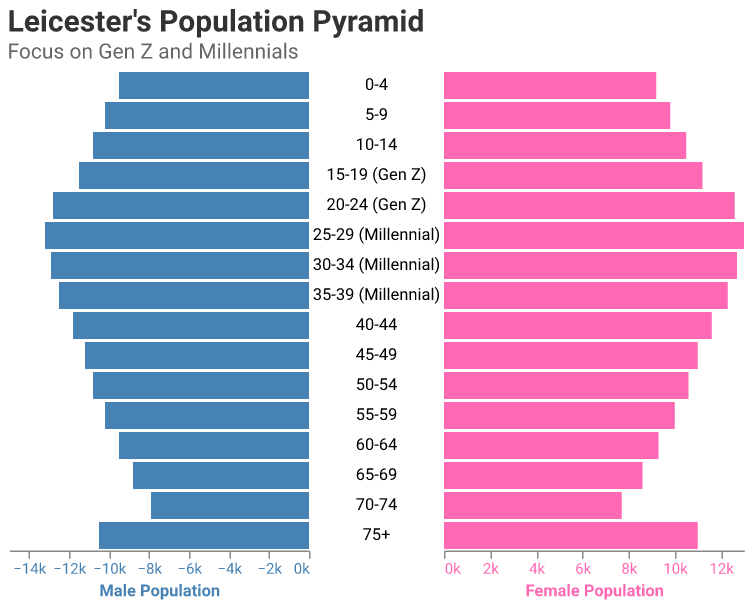What is the title of the figure? The title of the figure is displayed prominently at the top and says "Leicester's Population Pyramid", with a subtitle "Focus on Gen Z and Millennials".
Answer: Leicester's Population Pyramid What age group has the highest male population among Millennials? By examining the bars representing Millennials, the age group "25-29" has the longest bar for males, indicating the highest population.
Answer: 25-29 How does the female population of the 20-24 age group (Gen Z) compare to the male population of the same group? The female population bar for the 20-24 age group is slightly shorter than the male bar. The tooltip also shows females at 12,600 and males at 12,800.
Answer: Female population is slightly lower What is the total population (male and female) of the 35-39 age group (Millennial)? The male population is 12,500 and the female population is 12,300. Adding them together: 12,500 + 12,300 = 24,800.
Answer: 24,800 Which generation, Gen Z or Millennials, has a higher total population in Leicester? Summing the populations of each age group for both generations: 
- Gen Z: (11,500 + 11,200) + (12,800 + 12,600) = 48,100
- Millennials: (13,200 + 13,000) + (12,900 + 12,700) + (12,500 + 12,300) = 76,600
Therefore, Millennials have a higher total population.
Answer: Millennials What is the difference in male population between the 15-19 and 25-29 age groups? The male population for the 15-19 age group (Gen Z) is 11,500 and for the 25-29 age group (Millennial) is 13,200. The difference is 13,200 - 11,500 = 1,700.
Answer: 1,700 Which age group has a larger disparity between male and female populations: 65-69 or 75+? Examining both age groups:
- For 65-69: Male 8,800, Female 8,600. Difference is 200.
- For 75+: Male 10,500, Female 11,000. Difference is 500.
The 75+ age group has a larger disparity.
Answer: 75+ Between the 0-4 and 5-9 age groups, which has a higher male population? Comparing the lengths of the male population bars: 
- 0-4 age group: 9,500 males
- 5-9 age group: 10,200 males
The 5-9 age group has a higher male population.
Answer: 5-9 